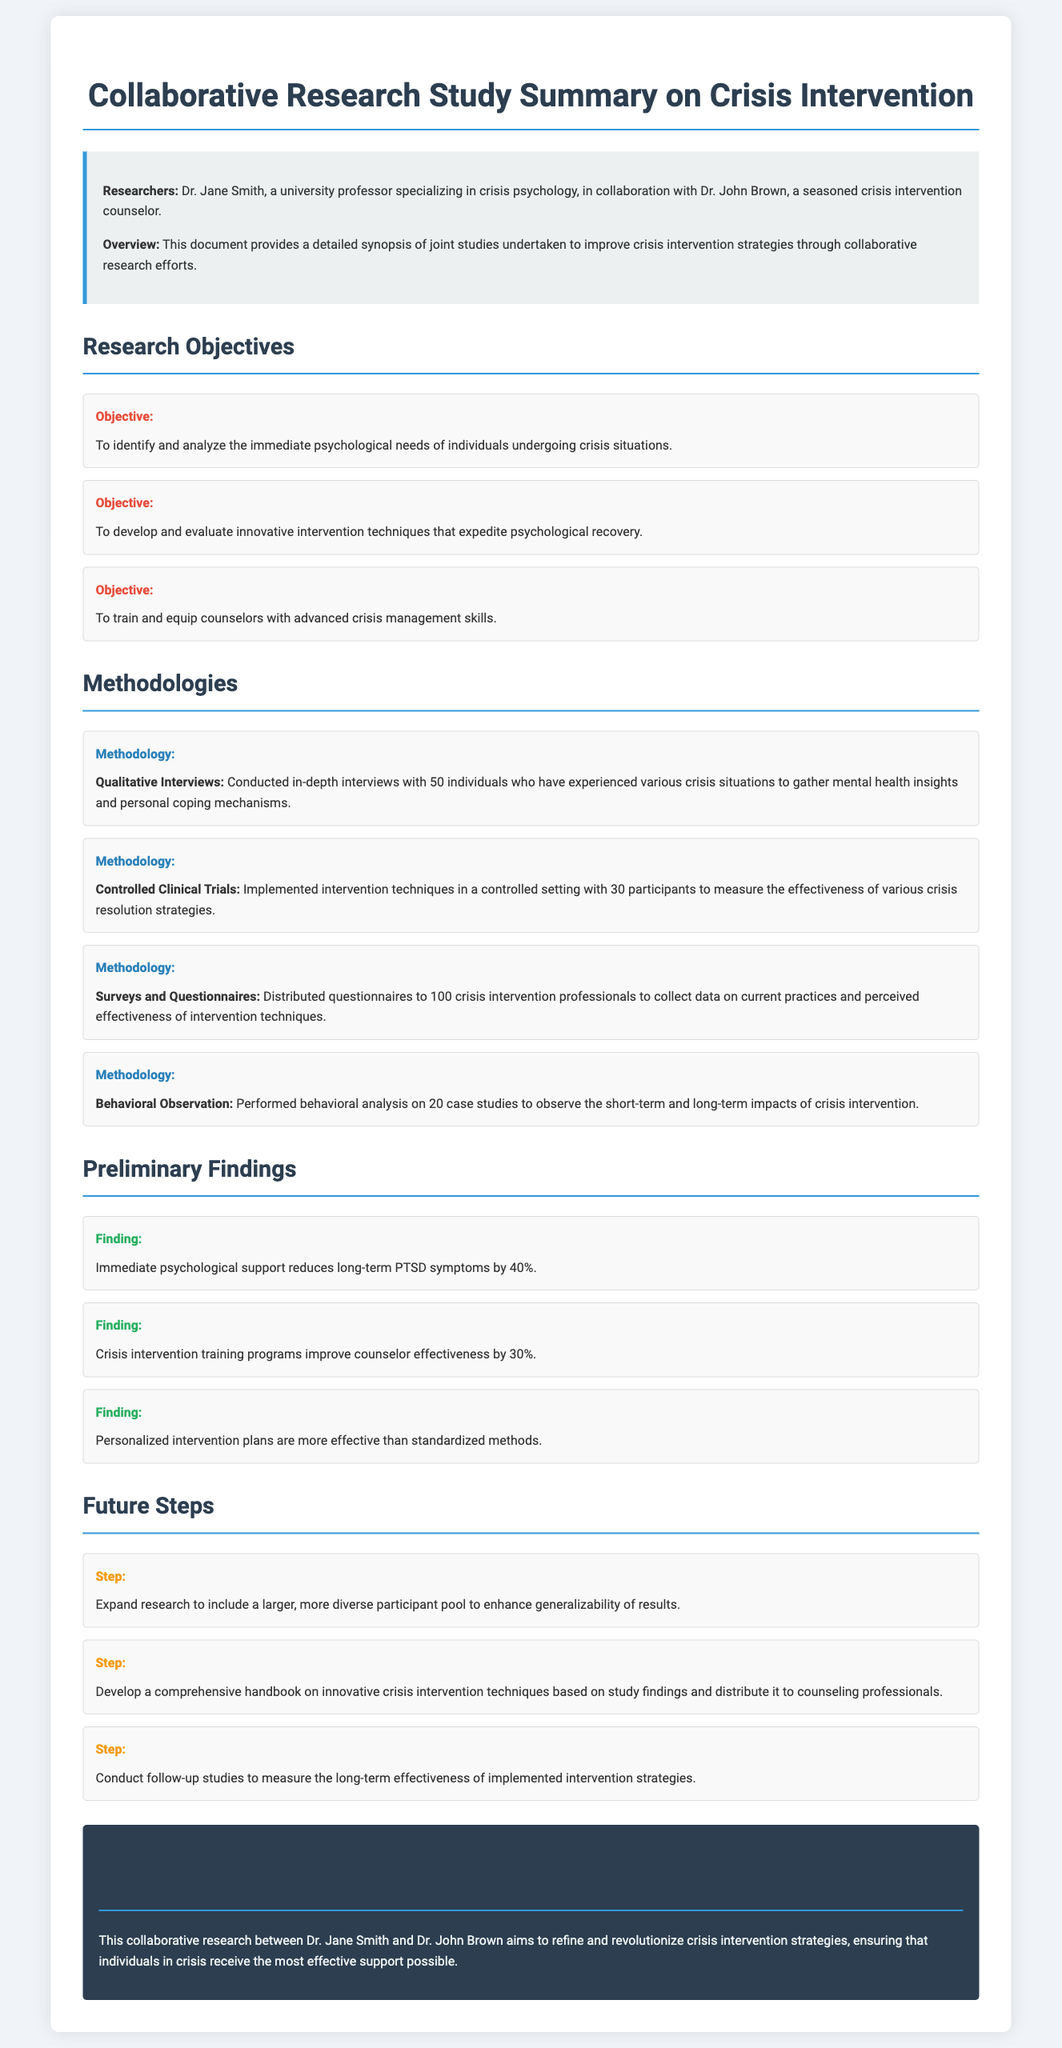What are the names of the researchers? The researchers mentioned in the document are Dr. Jane Smith and Dr. John Brown.
Answer: Dr. Jane Smith, Dr. John Brown What is one research objective? One of the listed objectives is to identify and analyze the immediate psychological needs of individuals undergoing crisis situations.
Answer: Identify and analyze immediate psychological needs How many qualitative interviews were conducted? The document states that in-depth interviews were conducted with 50 individuals experiencing crisis situations.
Answer: 50 What percentage does immediate psychological support reduce PTSD symptoms? According to the preliminary findings, immediate psychological support reduces long-term PTSD symptoms by 40%.
Answer: 40% What is one methodology used in the study? The study utilized several methodologies including qualitative interviews, controlled clinical trials, and behavioral observation. One example is qualitative interviews.
Answer: Qualitative Interviews What is the future step related to a handbook? The document mentions developing a comprehensive handbook on innovative crisis intervention techniques based on the study findings.
Answer: Develop a comprehensive handbook Which intervention technique is reported to improve counselor effectiveness? The findings indicate that crisis intervention training programs improve counselor effectiveness by 30%.
Answer: 30% What is the conclusion regarding crisis intervention strategies? The conclusion summarizes that the research aims to refine and revolutionize crisis intervention strategies to provide effective support.
Answer: Refine and revolutionize crisis intervention strategies 